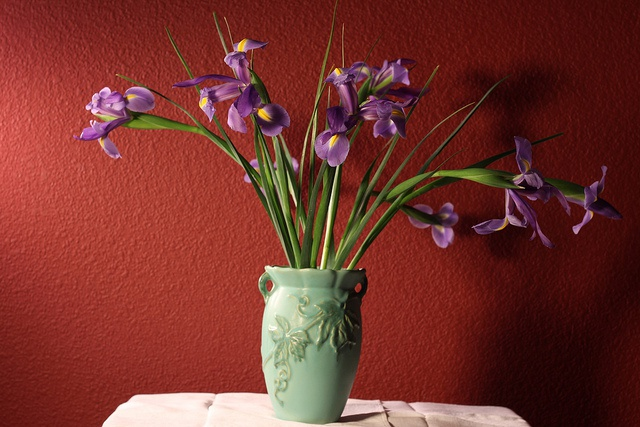Describe the objects in this image and their specific colors. I can see potted plant in maroon, black, brown, and darkgreen tones and vase in maroon, darkgray, black, darkgreen, and beige tones in this image. 